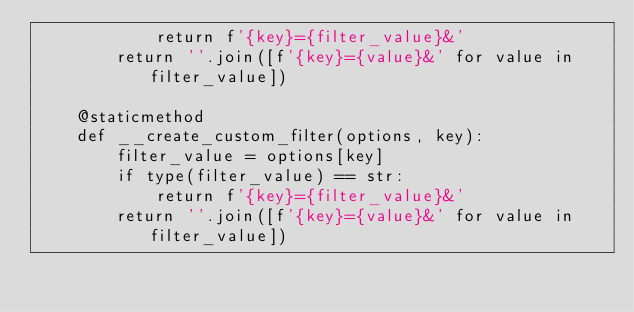Convert code to text. <code><loc_0><loc_0><loc_500><loc_500><_Python_>            return f'{key}={filter_value}&'
        return ''.join([f'{key}={value}&' for value in filter_value])

    @staticmethod
    def __create_custom_filter(options, key):
        filter_value = options[key]
        if type(filter_value) == str:
            return f'{key}={filter_value}&'
        return ''.join([f'{key}={value}&' for value in filter_value])
</code> 